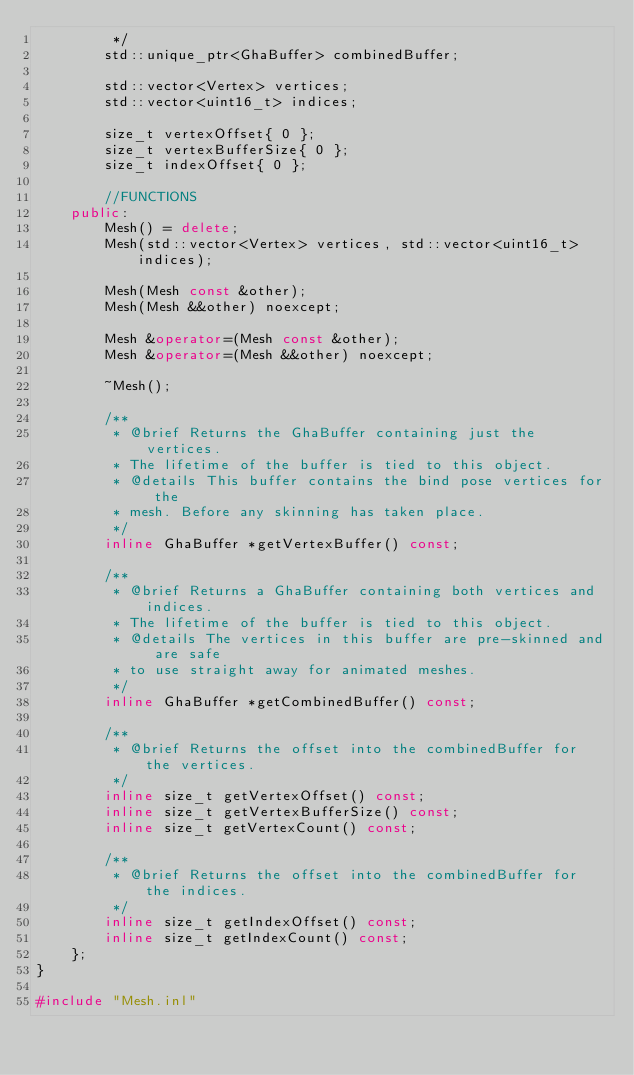<code> <loc_0><loc_0><loc_500><loc_500><_C++_>         */
        std::unique_ptr<GhaBuffer> combinedBuffer;

        std::vector<Vertex> vertices;
        std::vector<uint16_t> indices;

        size_t vertexOffset{ 0 };
        size_t vertexBufferSize{ 0 };
        size_t indexOffset{ 0 };

        //FUNCTIONS
    public:
        Mesh() = delete;
        Mesh(std::vector<Vertex> vertices, std::vector<uint16_t> indices);

        Mesh(Mesh const &other);
        Mesh(Mesh &&other) noexcept;

        Mesh &operator=(Mesh const &other);
        Mesh &operator=(Mesh &&other) noexcept;

        ~Mesh();

        /**
         * @brief Returns the GhaBuffer containing just the vertices.
         * The lifetime of the buffer is tied to this object.
         * @details This buffer contains the bind pose vertices for the
         * mesh. Before any skinning has taken place.
         */
        inline GhaBuffer *getVertexBuffer() const;

        /**
         * @brief Returns a GhaBuffer containing both vertices and indices.
         * The lifetime of the buffer is tied to this object.
         * @details The vertices in this buffer are pre-skinned and are safe
         * to use straight away for animated meshes.
         */
        inline GhaBuffer *getCombinedBuffer() const;

        /**
         * @brief Returns the offset into the combinedBuffer for the vertices.
         */
        inline size_t getVertexOffset() const;
        inline size_t getVertexBufferSize() const;
        inline size_t getVertexCount() const;

        /**
         * @brief Returns the offset into the combinedBuffer for the indices.
         */
        inline size_t getIndexOffset() const;
        inline size_t getIndexCount() const;
    };
}

#include "Mesh.inl"
</code> 